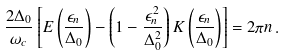Convert formula to latex. <formula><loc_0><loc_0><loc_500><loc_500>\frac { 2 \Delta _ { 0 } } { \omega _ { c } } \left [ E \left ( \frac { \epsilon _ { n } } { \Delta _ { 0 } } \right ) - \left ( 1 - \frac { \epsilon _ { n } ^ { 2 } } { \Delta _ { 0 } ^ { 2 } } \right ) K \left ( \frac { \epsilon _ { n } } { \Delta _ { 0 } } \right ) \right ] = 2 \pi n \, .</formula> 